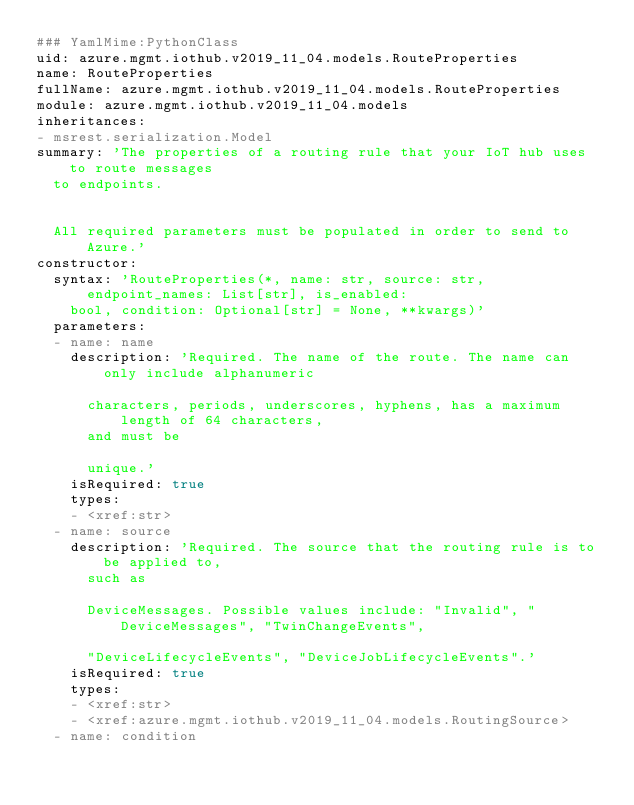<code> <loc_0><loc_0><loc_500><loc_500><_YAML_>### YamlMime:PythonClass
uid: azure.mgmt.iothub.v2019_11_04.models.RouteProperties
name: RouteProperties
fullName: azure.mgmt.iothub.v2019_11_04.models.RouteProperties
module: azure.mgmt.iothub.v2019_11_04.models
inheritances:
- msrest.serialization.Model
summary: 'The properties of a routing rule that your IoT hub uses to route messages
  to endpoints.


  All required parameters must be populated in order to send to Azure.'
constructor:
  syntax: 'RouteProperties(*, name: str, source: str, endpoint_names: List[str], is_enabled:
    bool, condition: Optional[str] = None, **kwargs)'
  parameters:
  - name: name
    description: 'Required. The name of the route. The name can only include alphanumeric

      characters, periods, underscores, hyphens, has a maximum length of 64 characters,
      and must be

      unique.'
    isRequired: true
    types:
    - <xref:str>
  - name: source
    description: 'Required. The source that the routing rule is to be applied to,
      such as

      DeviceMessages. Possible values include: "Invalid", "DeviceMessages", "TwinChangeEvents",

      "DeviceLifecycleEvents", "DeviceJobLifecycleEvents".'
    isRequired: true
    types:
    - <xref:str>
    - <xref:azure.mgmt.iothub.v2019_11_04.models.RoutingSource>
  - name: condition</code> 